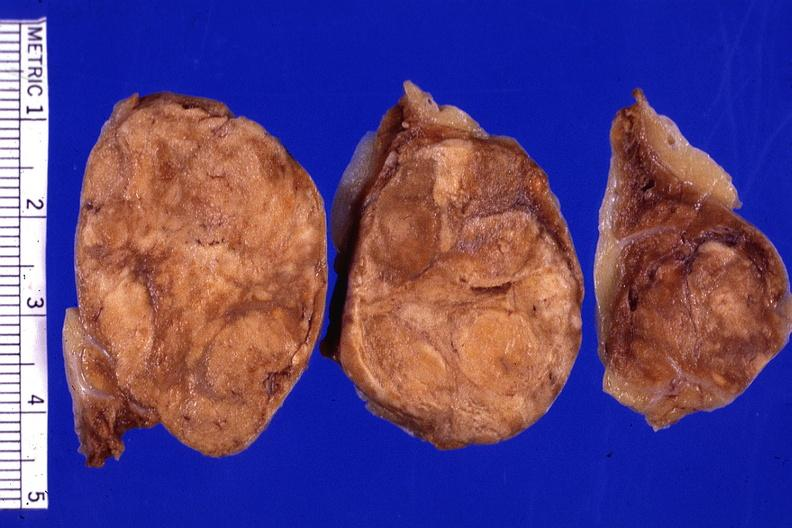does this image show cut surface 3 cm lesion very good?
Answer the question using a single word or phrase. Yes 